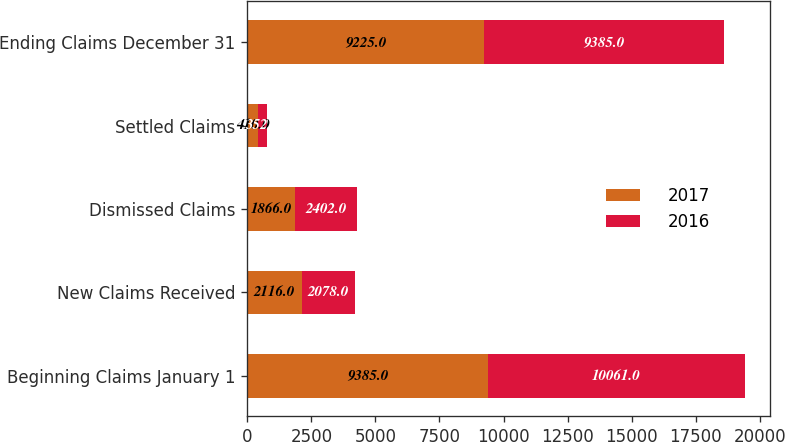Convert chart. <chart><loc_0><loc_0><loc_500><loc_500><stacked_bar_chart><ecel><fcel>Beginning Claims January 1<fcel>New Claims Received<fcel>Dismissed Claims<fcel>Settled Claims<fcel>Ending Claims December 31<nl><fcel>2017<fcel>9385<fcel>2116<fcel>1866<fcel>410<fcel>9225<nl><fcel>2016<fcel>10061<fcel>2078<fcel>2402<fcel>352<fcel>9385<nl></chart> 